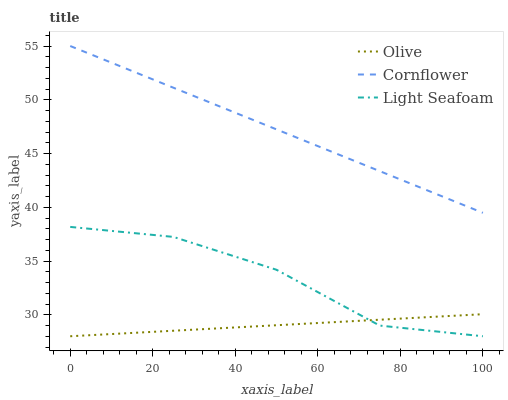Does Olive have the minimum area under the curve?
Answer yes or no. Yes. Does Cornflower have the maximum area under the curve?
Answer yes or no. Yes. Does Light Seafoam have the minimum area under the curve?
Answer yes or no. No. Does Light Seafoam have the maximum area under the curve?
Answer yes or no. No. Is Cornflower the smoothest?
Answer yes or no. Yes. Is Light Seafoam the roughest?
Answer yes or no. Yes. Is Light Seafoam the smoothest?
Answer yes or no. No. Is Cornflower the roughest?
Answer yes or no. No. Does Cornflower have the lowest value?
Answer yes or no. No. Does Cornflower have the highest value?
Answer yes or no. Yes. Does Light Seafoam have the highest value?
Answer yes or no. No. Is Light Seafoam less than Cornflower?
Answer yes or no. Yes. Is Cornflower greater than Light Seafoam?
Answer yes or no. Yes. Does Light Seafoam intersect Olive?
Answer yes or no. Yes. Is Light Seafoam less than Olive?
Answer yes or no. No. Is Light Seafoam greater than Olive?
Answer yes or no. No. Does Light Seafoam intersect Cornflower?
Answer yes or no. No. 